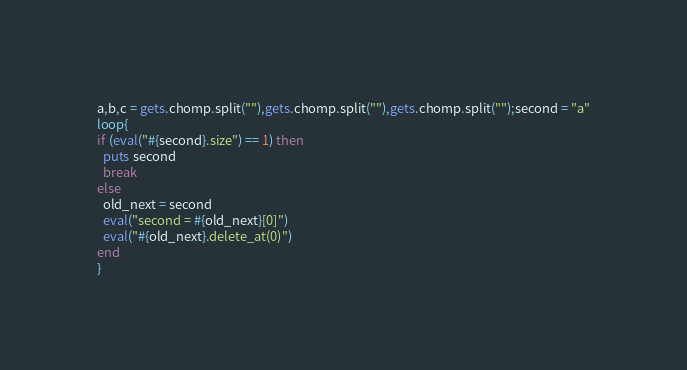<code> <loc_0><loc_0><loc_500><loc_500><_Ruby_>a,b,c = gets.chomp.split(""),gets.chomp.split(""),gets.chomp.split("");second = "a"
loop{
if (eval("#{second}.size") == 1) then
  puts second
  break
else
  old_next = second
  eval("second = #{old_next}[0]")
  eval("#{old_next}.delete_at(0)")
end
}
</code> 